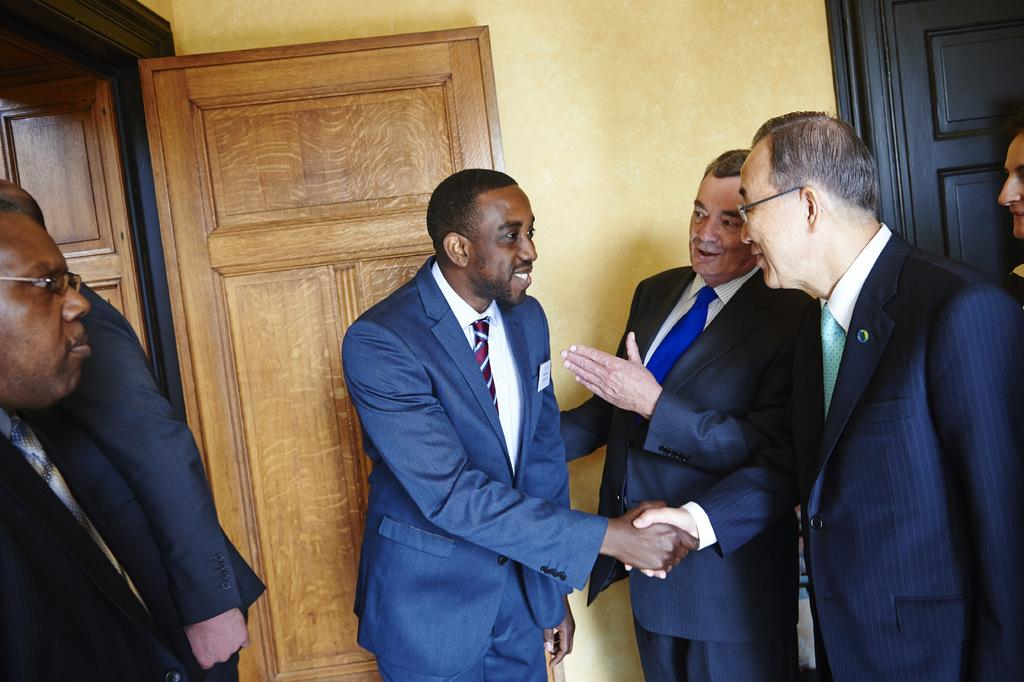Who is present in the image? There are men in the image. What are the men wearing? The men are wearing blue suits. What are the men doing in the image? The men are welcoming a guest and shaking hands with the guest. What can be seen in the background of the image? There is a brown wooden door and a yellow wall in the background. What type of quill is the guest using to sign a document in the image? There is no quill or document signing activity depicted in the image; the men are simply shaking hands. 